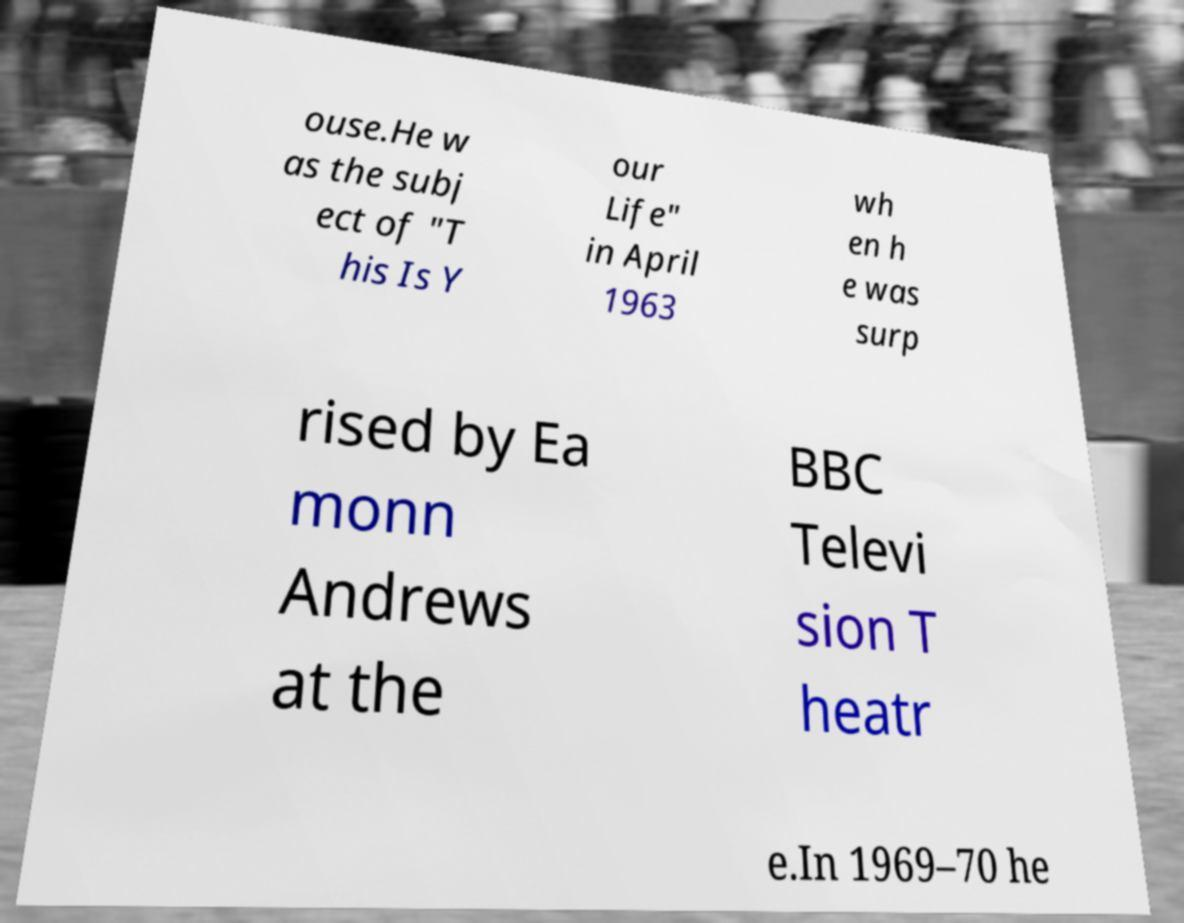Can you read and provide the text displayed in the image?This photo seems to have some interesting text. Can you extract and type it out for me? ouse.He w as the subj ect of "T his Is Y our Life" in April 1963 wh en h e was surp rised by Ea monn Andrews at the BBC Televi sion T heatr e.In 1969–70 he 